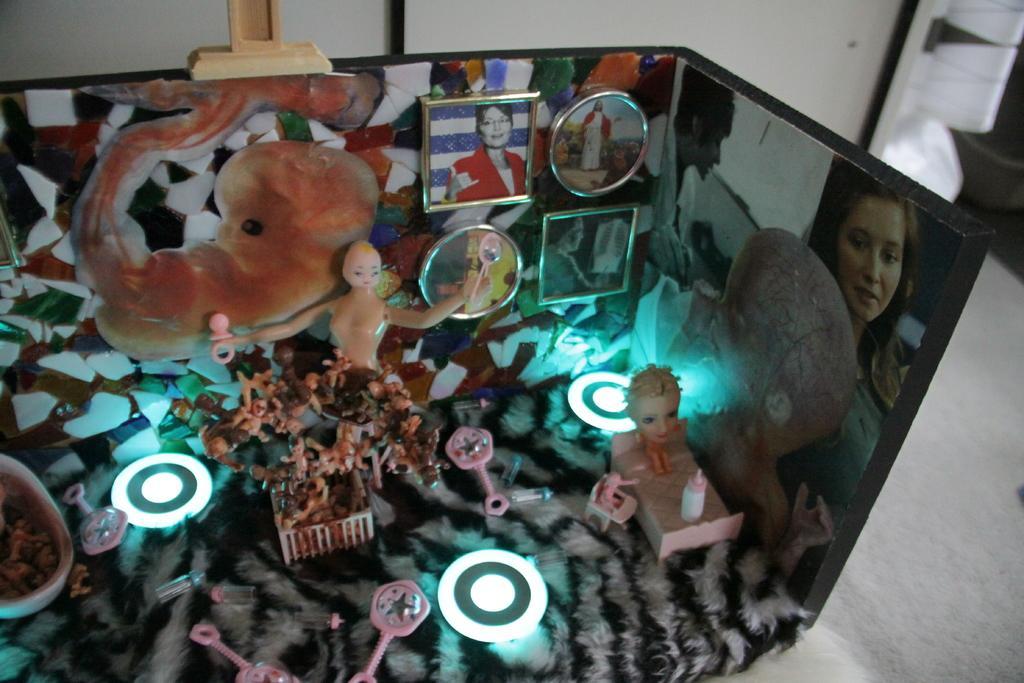In one or two sentences, can you explain what this image depicts? In this image we can see toys placed here and photo frames on the wall. Here we can see a man and a woman pictures on the wall. In the background, we can see a wall and something which is in white color. 